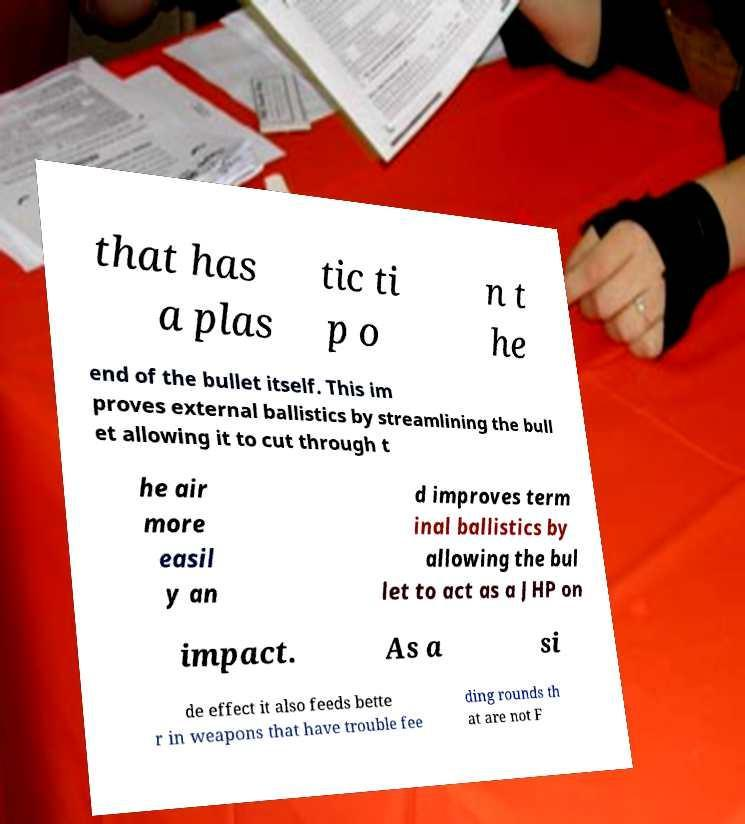Please identify and transcribe the text found in this image. that has a plas tic ti p o n t he end of the bullet itself. This im proves external ballistics by streamlining the bull et allowing it to cut through t he air more easil y an d improves term inal ballistics by allowing the bul let to act as a JHP on impact. As a si de effect it also feeds bette r in weapons that have trouble fee ding rounds th at are not F 